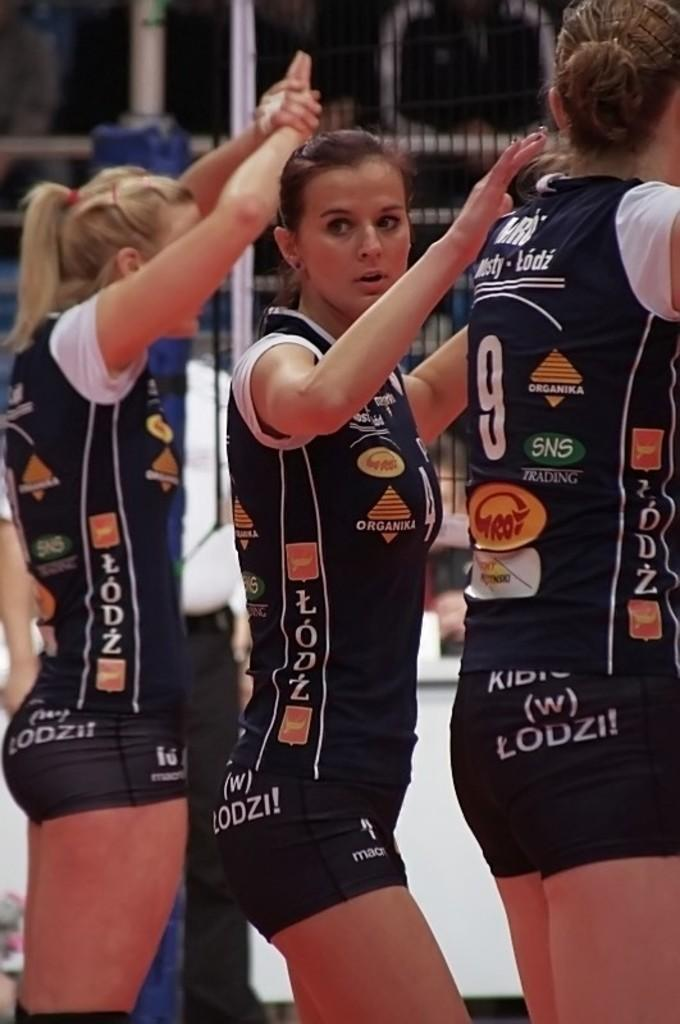<image>
Give a short and clear explanation of the subsequent image. Young women wearing jerseys that are printed LODZ stand with their hands up. 